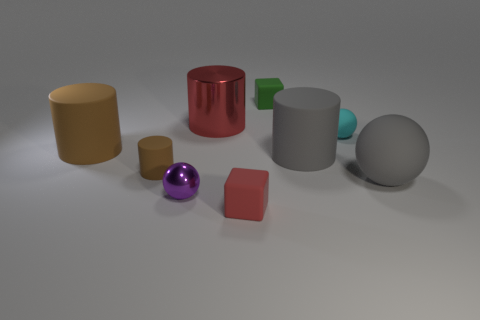Is there any other thing that is the same color as the small shiny thing?
Provide a succinct answer. No. There is a big cylinder that is to the right of the green rubber cube; what is it made of?
Offer a very short reply. Rubber. Do the red metallic cylinder and the purple metal ball have the same size?
Offer a terse response. No. How many other things are there of the same size as the green matte object?
Make the answer very short. 4. Is the color of the big sphere the same as the tiny shiny sphere?
Provide a succinct answer. No. There is a red object that is behind the tiny cyan sphere on the right side of the large matte cylinder on the right side of the big red shiny cylinder; what is its shape?
Your answer should be very brief. Cylinder. How many things are either balls behind the big gray rubber ball or cylinders in front of the red shiny thing?
Your answer should be very brief. 4. There is a metallic object that is in front of the gray ball that is in front of the cyan rubber object; what size is it?
Your response must be concise. Small. Do the tiny rubber block that is on the right side of the red rubber thing and the large metal object have the same color?
Ensure brevity in your answer.  No. Are there any red matte objects of the same shape as the green object?
Your answer should be compact. Yes. 